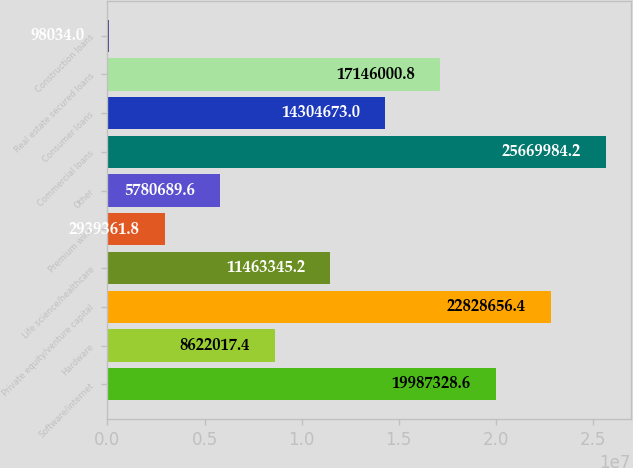<chart> <loc_0><loc_0><loc_500><loc_500><bar_chart><fcel>Software/internet<fcel>Hardware<fcel>Private equity/venture capital<fcel>Life science/healthcare<fcel>Premium wine<fcel>Other<fcel>Commercial loans<fcel>Consumer loans<fcel>Real estate secured loans<fcel>Construction loans<nl><fcel>1.99873e+07<fcel>8.62202e+06<fcel>2.28287e+07<fcel>1.14633e+07<fcel>2.93936e+06<fcel>5.78069e+06<fcel>2.567e+07<fcel>1.43047e+07<fcel>1.7146e+07<fcel>98034<nl></chart> 